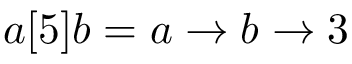<formula> <loc_0><loc_0><loc_500><loc_500>a [ 5 ] b = a \rightarrow b \rightarrow 3</formula> 